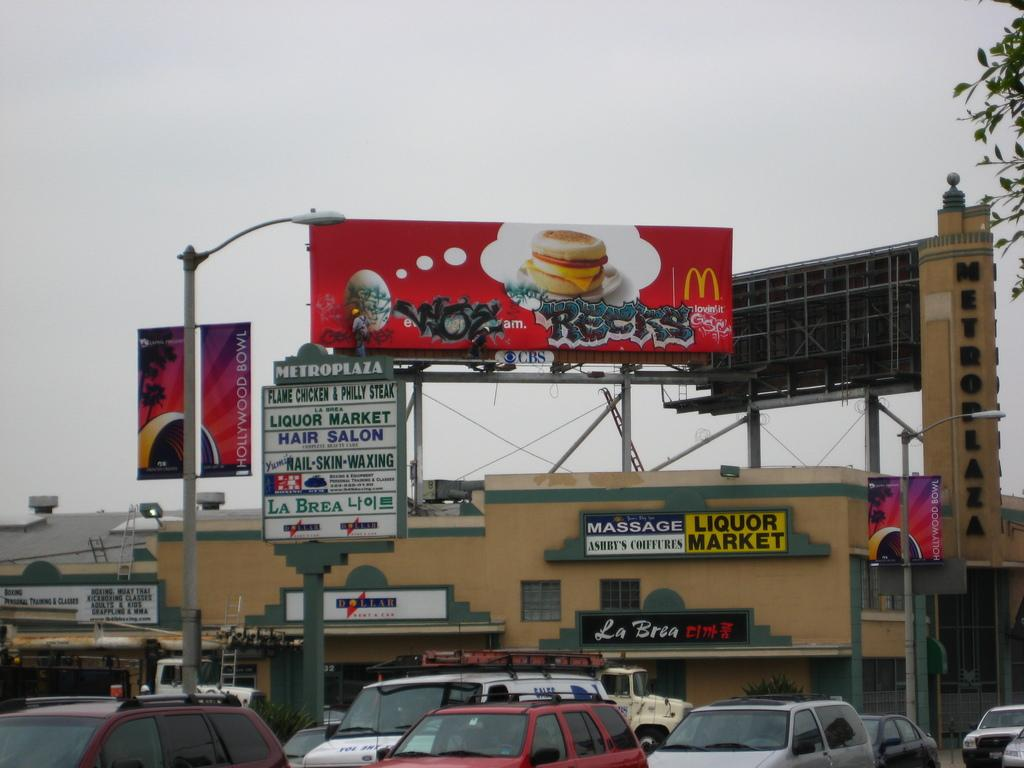<image>
Describe the image concisely. Above the Liquor Market there is a McDonald's billboard with graffiti across it. 